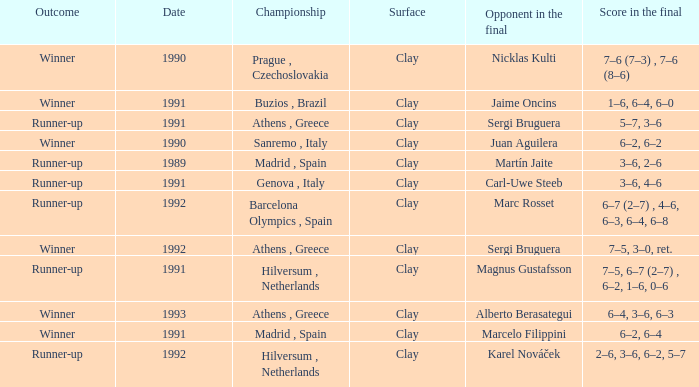What is Score In The Final, when Championship is "Athens , Greece", and when Outcome is "Winner"? 7–5, 3–0, ret., 6–4, 3–6, 6–3. 